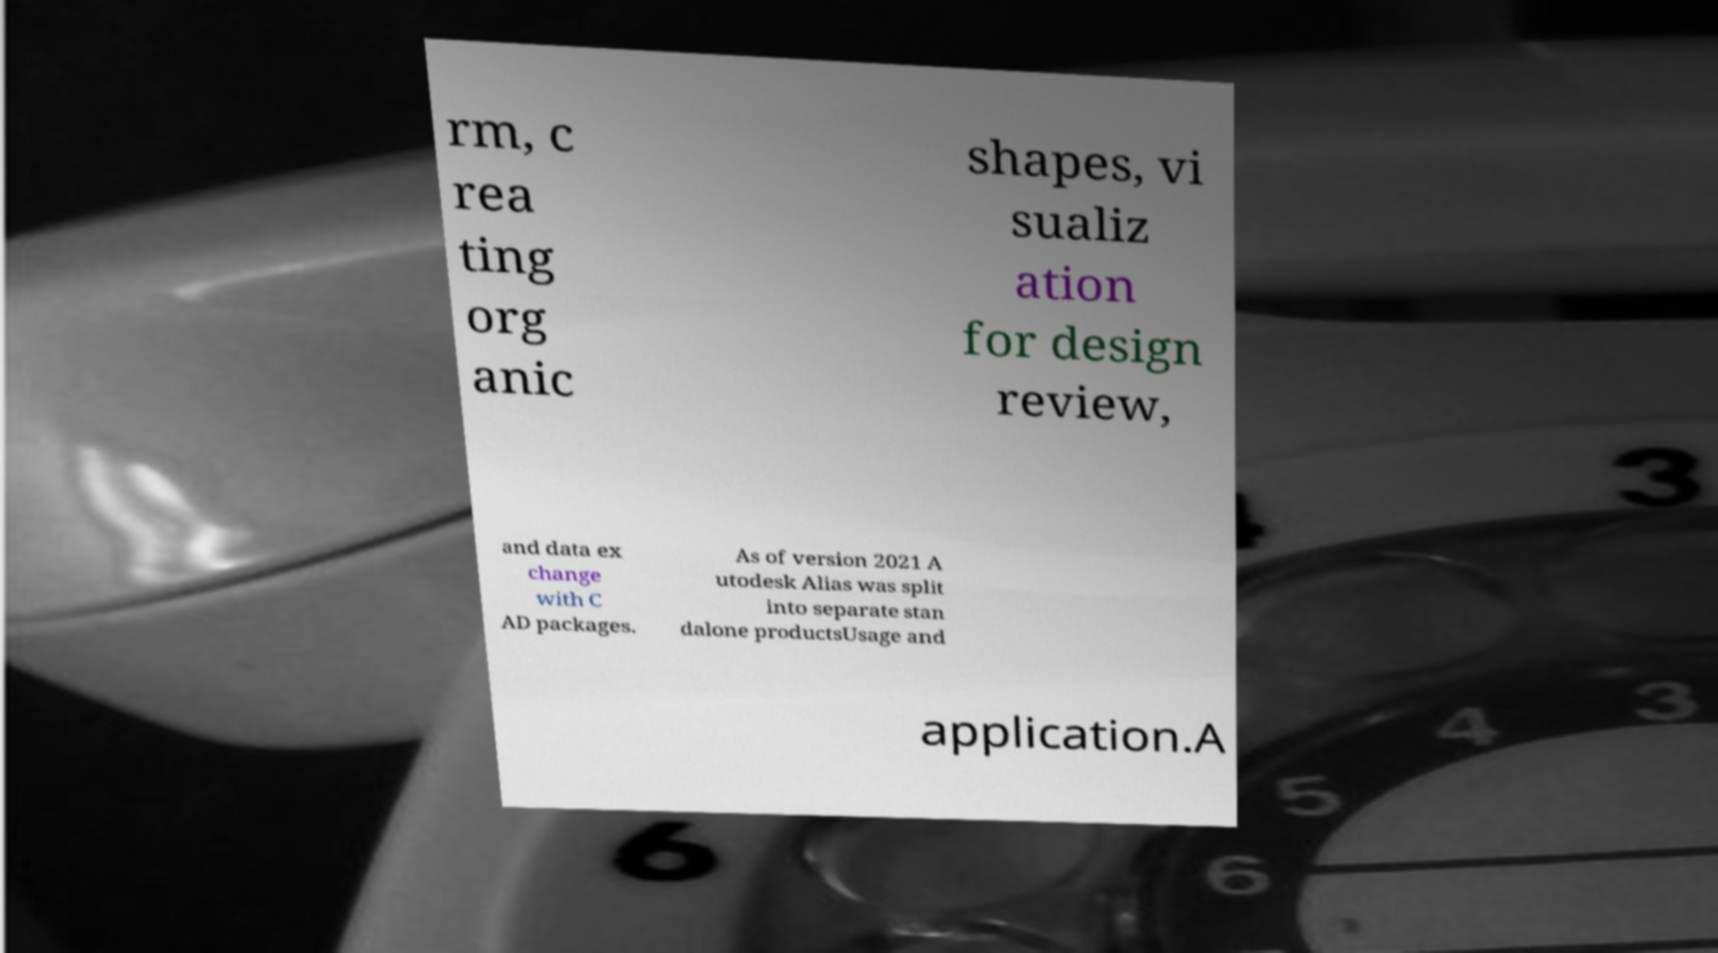There's text embedded in this image that I need extracted. Can you transcribe it verbatim? rm, c rea ting org anic shapes, vi sualiz ation for design review, and data ex change with C AD packages. As of version 2021 A utodesk Alias was split into separate stan dalone productsUsage and application.A 